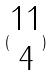<formula> <loc_0><loc_0><loc_500><loc_500>( \begin{matrix} 1 1 \\ 4 \end{matrix} )</formula> 